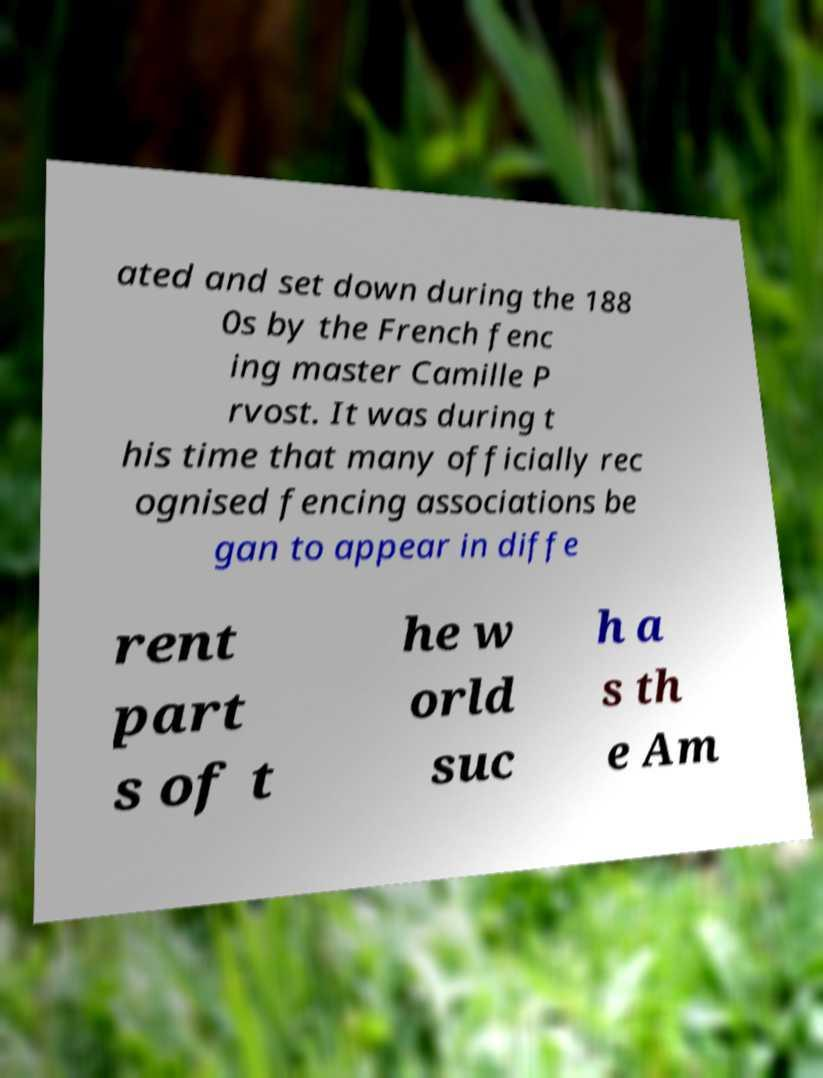Please identify and transcribe the text found in this image. ated and set down during the 188 0s by the French fenc ing master Camille P rvost. It was during t his time that many officially rec ognised fencing associations be gan to appear in diffe rent part s of t he w orld suc h a s th e Am 